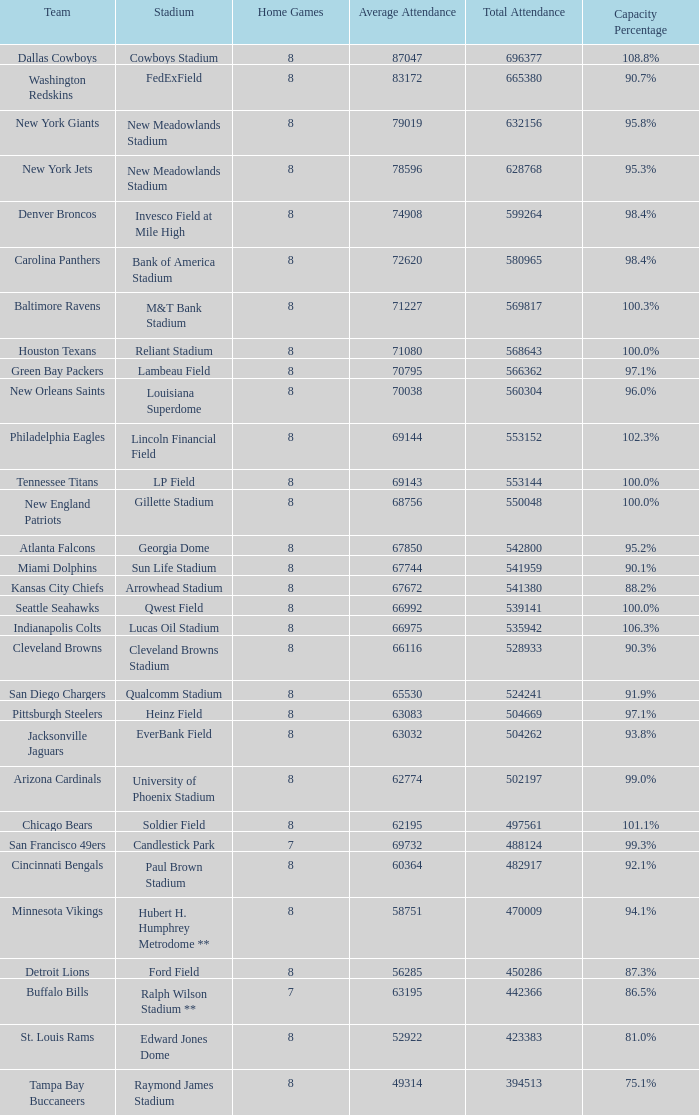3%? Philadelphia Eagles. 